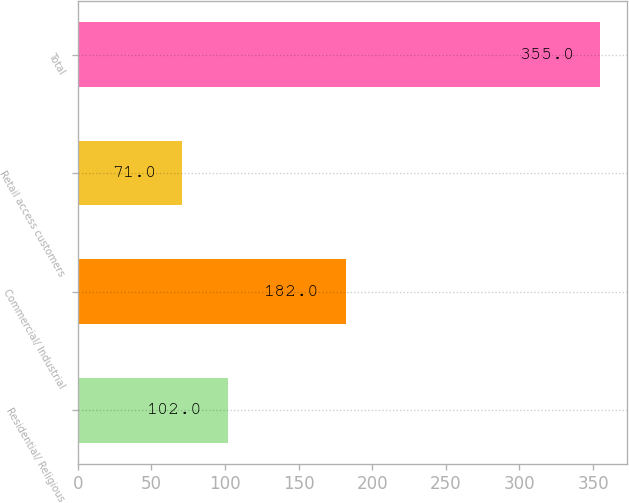Convert chart. <chart><loc_0><loc_0><loc_500><loc_500><bar_chart><fcel>Residential/ Religious<fcel>Commercial/ Industrial<fcel>Retail access customers<fcel>Total<nl><fcel>102<fcel>182<fcel>71<fcel>355<nl></chart> 